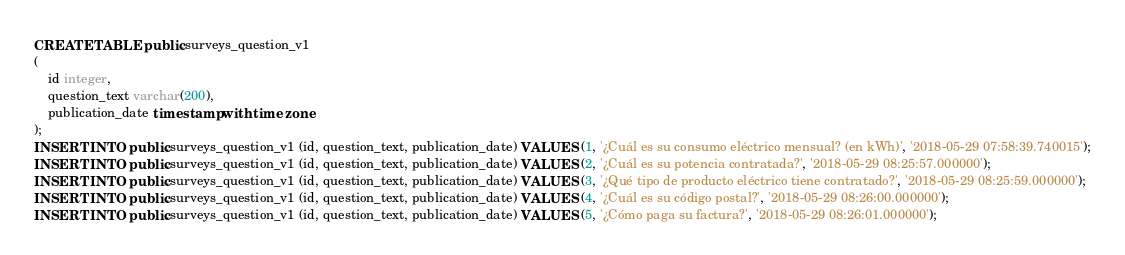Convert code to text. <code><loc_0><loc_0><loc_500><loc_500><_SQL_>CREATE TABLE public.surveys_question_v1
(
    id integer,
    question_text varchar(200),
    publication_date timestamp with time zone
);
INSERT INTO public.surveys_question_v1 (id, question_text, publication_date) VALUES (1, '¿Cuál es su consumo eléctrico mensual? (en kWh)', '2018-05-29 07:58:39.740015');
INSERT INTO public.surveys_question_v1 (id, question_text, publication_date) VALUES (2, '¿Cuál es su potencia contratada?', '2018-05-29 08:25:57.000000');
INSERT INTO public.surveys_question_v1 (id, question_text, publication_date) VALUES (3, '¿Qué tipo de producto eléctrico tiene contratado?', '2018-05-29 08:25:59.000000');
INSERT INTO public.surveys_question_v1 (id, question_text, publication_date) VALUES (4, '¿Cuál es su código postal?', '2018-05-29 08:26:00.000000');
INSERT INTO public.surveys_question_v1 (id, question_text, publication_date) VALUES (5, '¿Cómo paga su factura?', '2018-05-29 08:26:01.000000');</code> 